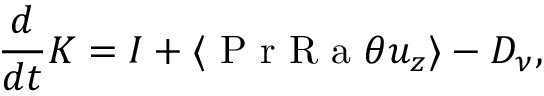Convert formula to latex. <formula><loc_0><loc_0><loc_500><loc_500>\frac { d } { d t } K = I + \langle P r R a \theta u _ { z } \rangle - D _ { \nu } ,</formula> 